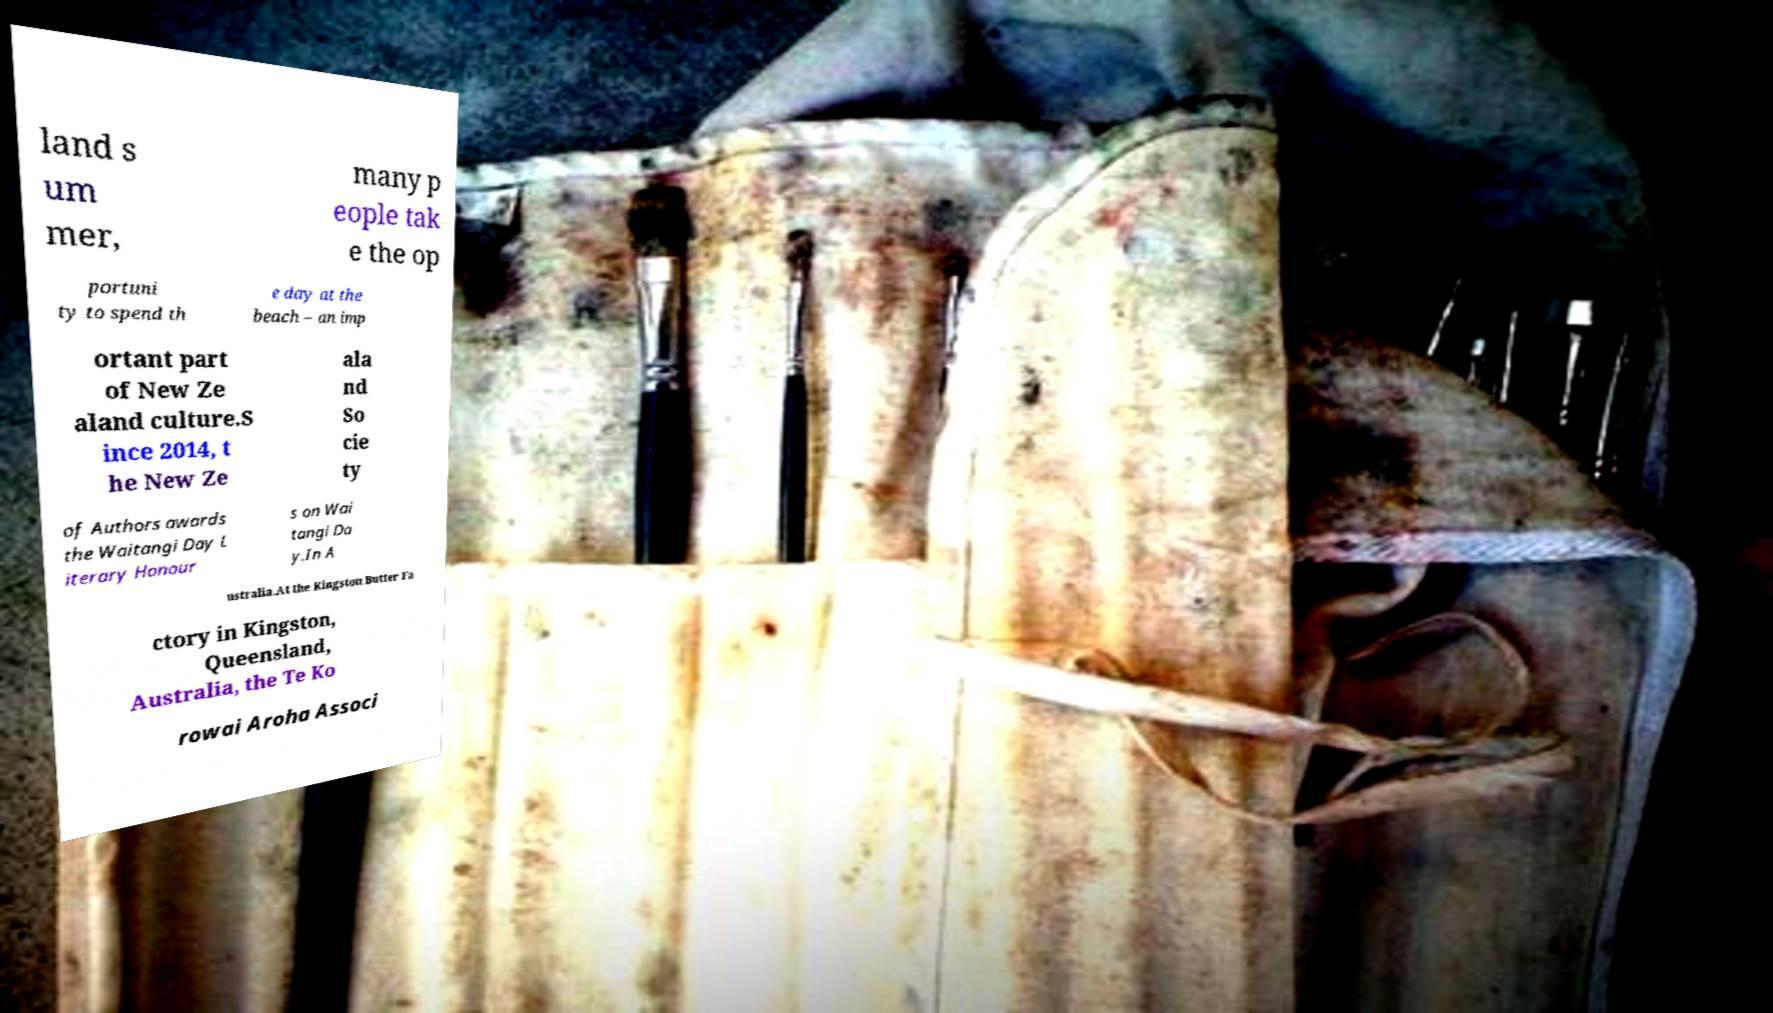Can you accurately transcribe the text from the provided image for me? land s um mer, many p eople tak e the op portuni ty to spend th e day at the beach – an imp ortant part of New Ze aland culture.S ince 2014, t he New Ze ala nd So cie ty of Authors awards the Waitangi Day L iterary Honour s on Wai tangi Da y.In A ustralia.At the Kingston Butter Fa ctory in Kingston, Queensland, Australia, the Te Ko rowai Aroha Associ 